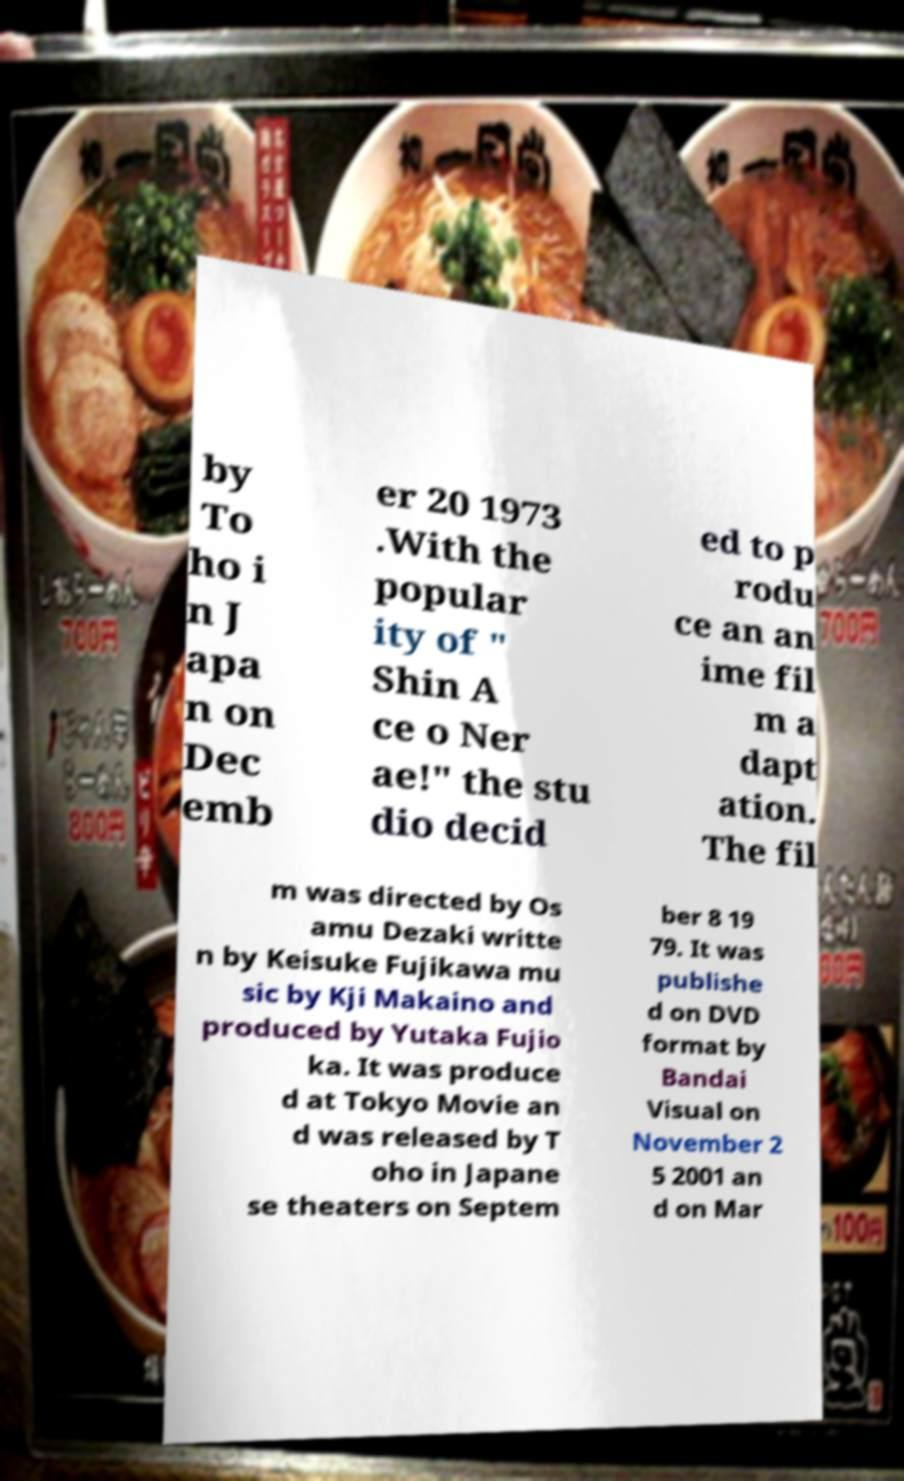Can you read and provide the text displayed in the image?This photo seems to have some interesting text. Can you extract and type it out for me? by To ho i n J apa n on Dec emb er 20 1973 .With the popular ity of " Shin A ce o Ner ae!" the stu dio decid ed to p rodu ce an an ime fil m a dapt ation. The fil m was directed by Os amu Dezaki writte n by Keisuke Fujikawa mu sic by Kji Makaino and produced by Yutaka Fujio ka. It was produce d at Tokyo Movie an d was released by T oho in Japane se theaters on Septem ber 8 19 79. It was publishe d on DVD format by Bandai Visual on November 2 5 2001 an d on Mar 